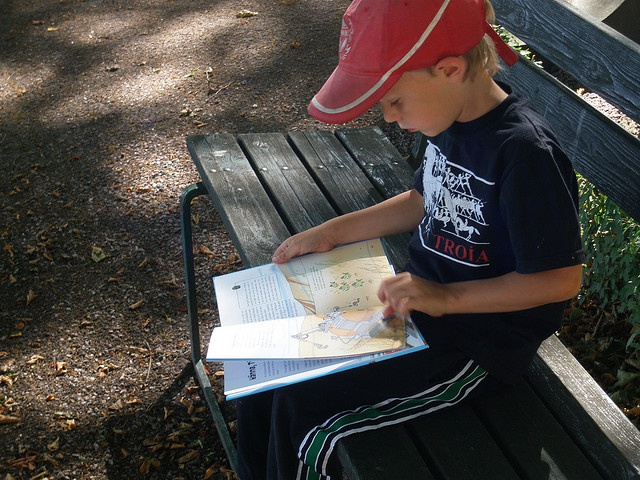Describe the objects in this image and their specific colors. I can see people in black, maroon, brown, and gray tones, bench in black, gray, darkgray, and blue tones, and book in black, white, darkgray, and tan tones in this image. 